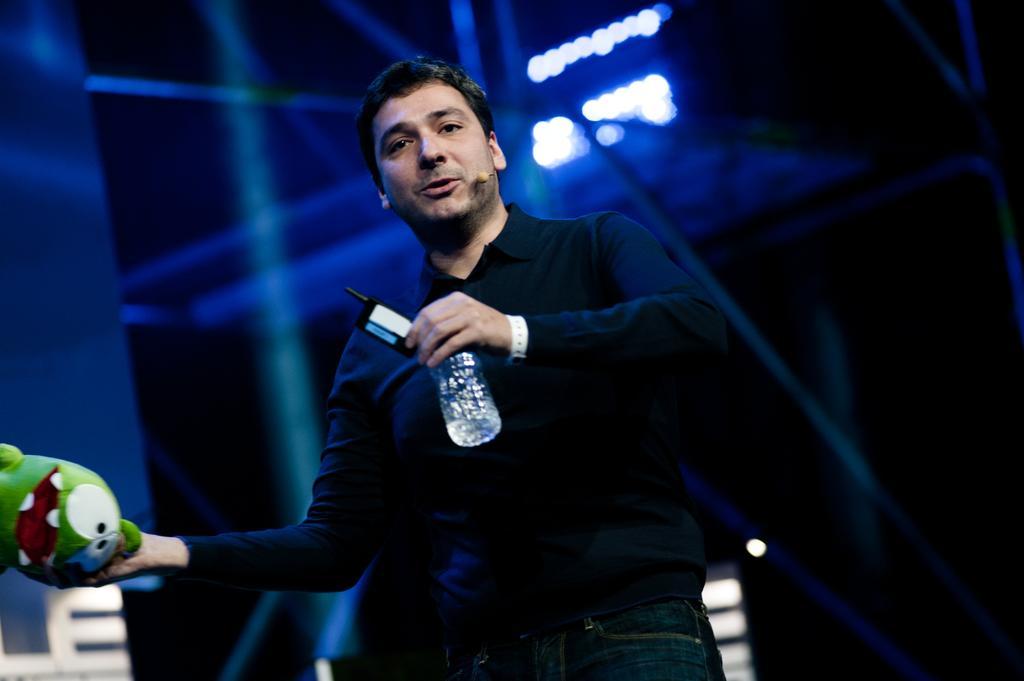Describe this image in one or two sentences. In this image we can see a person wearing black T-shirt is holding a bottle and toy in his hands and standing here. The background of the image is dark and slightly blurred. 